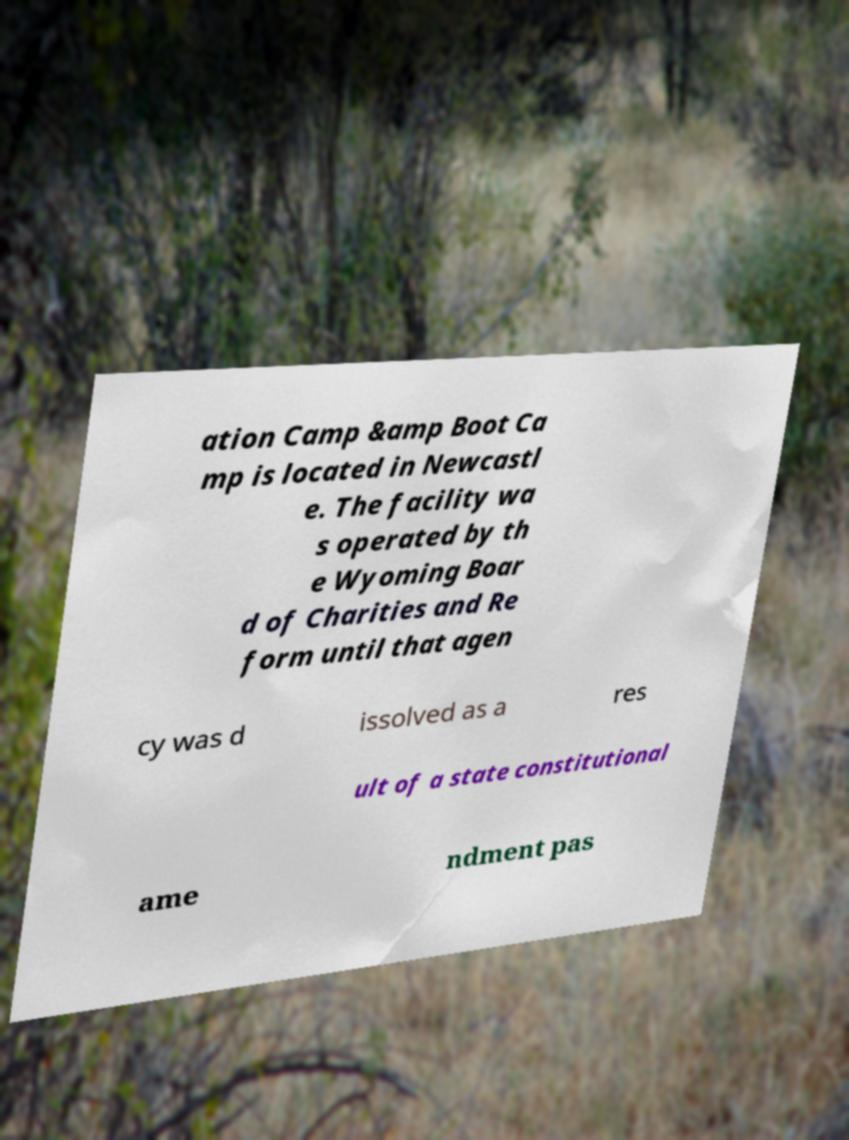What messages or text are displayed in this image? I need them in a readable, typed format. ation Camp &amp Boot Ca mp is located in Newcastl e. The facility wa s operated by th e Wyoming Boar d of Charities and Re form until that agen cy was d issolved as a res ult of a state constitutional ame ndment pas 